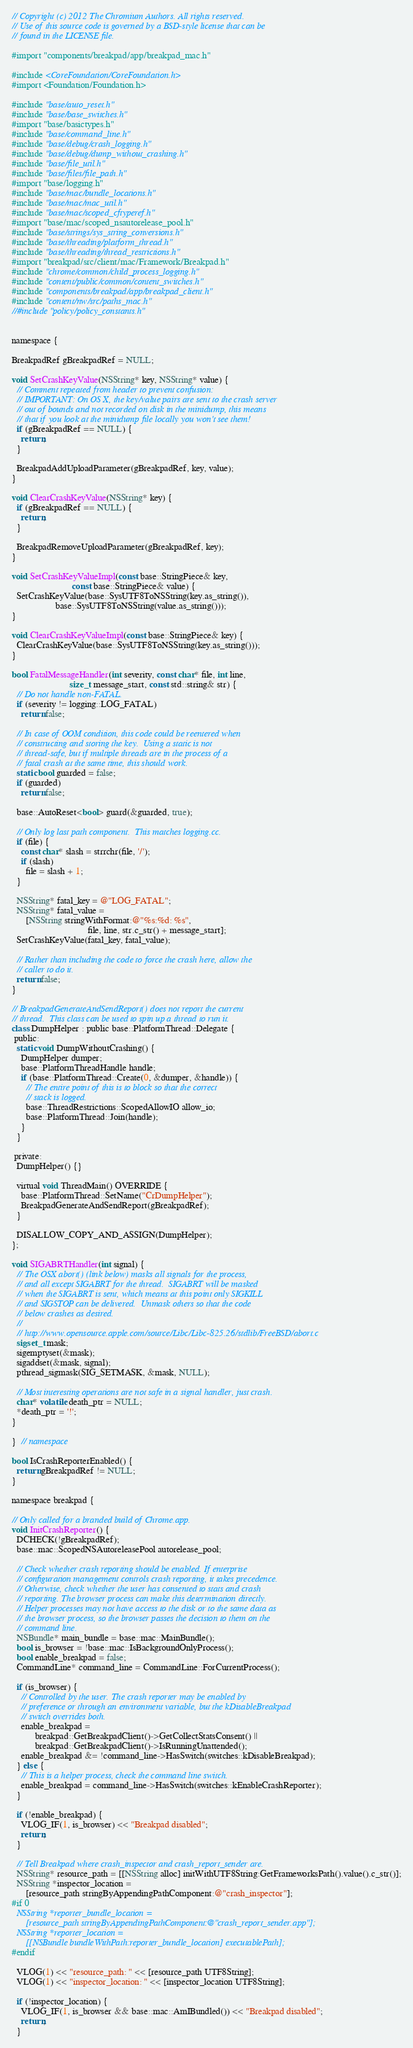Convert code to text. <code><loc_0><loc_0><loc_500><loc_500><_ObjectiveC_>// Copyright (c) 2012 The Chromium Authors. All rights reserved.
// Use of this source code is governed by a BSD-style license that can be
// found in the LICENSE file.

#import "components/breakpad/app/breakpad_mac.h"

#include <CoreFoundation/CoreFoundation.h>
#import <Foundation/Foundation.h>

#include "base/auto_reset.h"
#include "base/base_switches.h"
#import "base/basictypes.h"
#include "base/command_line.h"
#include "base/debug/crash_logging.h"
#include "base/debug/dump_without_crashing.h"
#include "base/file_util.h"
#include "base/files/file_path.h"
#import "base/logging.h"
#include "base/mac/bundle_locations.h"
#include "base/mac/mac_util.h"
#include "base/mac/scoped_cftyperef.h"
#import "base/mac/scoped_nsautorelease_pool.h"
#include "base/strings/sys_string_conversions.h"
#include "base/threading/platform_thread.h"
#include "base/threading/thread_restrictions.h"
#import "breakpad/src/client/mac/Framework/Breakpad.h"
#include "chrome/common/child_process_logging.h"
#include "content/public/common/content_switches.h"
#include "components/breakpad/app/breakpad_client.h"
#include "content/nw/src/paths_mac.h"
//#include "policy/policy_constants.h"


namespace {

BreakpadRef gBreakpadRef = NULL;

void SetCrashKeyValue(NSString* key, NSString* value) {
  // Comment repeated from header to prevent confusion:
  // IMPORTANT: On OS X, the key/value pairs are sent to the crash server
  // out of bounds and not recorded on disk in the minidump, this means
  // that if you look at the minidump file locally you won't see them!
  if (gBreakpadRef == NULL) {
    return;
  }

  BreakpadAddUploadParameter(gBreakpadRef, key, value);
}

void ClearCrashKeyValue(NSString* key) {
  if (gBreakpadRef == NULL) {
    return;
  }

  BreakpadRemoveUploadParameter(gBreakpadRef, key);
}

void SetCrashKeyValueImpl(const base::StringPiece& key,
                          const base::StringPiece& value) {
  SetCrashKeyValue(base::SysUTF8ToNSString(key.as_string()),
                   base::SysUTF8ToNSString(value.as_string()));
}

void ClearCrashKeyValueImpl(const base::StringPiece& key) {
  ClearCrashKeyValue(base::SysUTF8ToNSString(key.as_string()));
}

bool FatalMessageHandler(int severity, const char* file, int line,
                         size_t message_start, const std::string& str) {
  // Do not handle non-FATAL.
  if (severity != logging::LOG_FATAL)
    return false;

  // In case of OOM condition, this code could be reentered when
  // constructing and storing the key.  Using a static is not
  // thread-safe, but if multiple threads are in the process of a
  // fatal crash at the same time, this should work.
  static bool guarded = false;
  if (guarded)
    return false;

  base::AutoReset<bool> guard(&guarded, true);

  // Only log last path component.  This matches logging.cc.
  if (file) {
    const char* slash = strrchr(file, '/');
    if (slash)
      file = slash + 1;
  }

  NSString* fatal_key = @"LOG_FATAL";
  NSString* fatal_value =
      [NSString stringWithFormat:@"%s:%d: %s",
                                 file, line, str.c_str() + message_start];
  SetCrashKeyValue(fatal_key, fatal_value);

  // Rather than including the code to force the crash here, allow the
  // caller to do it.
  return false;
}

// BreakpadGenerateAndSendReport() does not report the current
// thread.  This class can be used to spin up a thread to run it.
class DumpHelper : public base::PlatformThread::Delegate {
 public:
  static void DumpWithoutCrashing() {
    DumpHelper dumper;
    base::PlatformThreadHandle handle;
    if (base::PlatformThread::Create(0, &dumper, &handle)) {
      // The entire point of this is to block so that the correct
      // stack is logged.
      base::ThreadRestrictions::ScopedAllowIO allow_io;
      base::PlatformThread::Join(handle);
    }
  }

 private:
  DumpHelper() {}

  virtual void ThreadMain() OVERRIDE {
    base::PlatformThread::SetName("CrDumpHelper");
    BreakpadGenerateAndSendReport(gBreakpadRef);
  }

  DISALLOW_COPY_AND_ASSIGN(DumpHelper);
};

void SIGABRTHandler(int signal) {
  // The OSX abort() (link below) masks all signals for the process,
  // and all except SIGABRT for the thread.  SIGABRT will be masked
  // when the SIGABRT is sent, which means at this point only SIGKILL
  // and SIGSTOP can be delivered.  Unmask others so that the code
  // below crashes as desired.
  //
  // http://www.opensource.apple.com/source/Libc/Libc-825.26/stdlib/FreeBSD/abort.c
  sigset_t mask;
  sigemptyset(&mask);
  sigaddset(&mask, signal);
  pthread_sigmask(SIG_SETMASK, &mask, NULL);

  // Most interesting operations are not safe in a signal handler, just crash.
  char* volatile death_ptr = NULL;
  *death_ptr = '!';
}

}  // namespace

bool IsCrashReporterEnabled() {
  return gBreakpadRef != NULL;
}

namespace breakpad {

// Only called for a branded build of Chrome.app.
void InitCrashReporter() {
  DCHECK(!gBreakpadRef);
  base::mac::ScopedNSAutoreleasePool autorelease_pool;

  // Check whether crash reporting should be enabled. If enterprise
  // configuration management controls crash reporting, it takes precedence.
  // Otherwise, check whether the user has consented to stats and crash
  // reporting. The browser process can make this determination directly.
  // Helper processes may not have access to the disk or to the same data as
  // the browser process, so the browser passes the decision to them on the
  // command line.
  NSBundle* main_bundle = base::mac::MainBundle();
  bool is_browser = !base::mac::IsBackgroundOnlyProcess();
  bool enable_breakpad = false;
  CommandLine* command_line = CommandLine::ForCurrentProcess();

  if (is_browser) {
    // Controlled by the user. The crash reporter may be enabled by
    // preference or through an environment variable, but the kDisableBreakpad
    // switch overrides both.
    enable_breakpad =
          breakpad::GetBreakpadClient()->GetCollectStatsConsent() ||
          breakpad::GetBreakpadClient()->IsRunningUnattended();
    enable_breakpad &= !command_line->HasSwitch(switches::kDisableBreakpad);
  } else {
    // This is a helper process, check the command line switch.
    enable_breakpad = command_line->HasSwitch(switches::kEnableCrashReporter);
  }

  if (!enable_breakpad) {
    VLOG_IF(1, is_browser) << "Breakpad disabled";
    return;
  }

  // Tell Breakpad where crash_inspector and crash_report_sender are.
  NSString* resource_path = [[NSString alloc] initWithUTF8String:GetFrameworksPath().value().c_str()];
  NSString *inspector_location =
      [resource_path stringByAppendingPathComponent:@"crash_inspector"];
#if 0
  NSString *reporter_bundle_location =
      [resource_path stringByAppendingPathComponent:@"crash_report_sender.app"];
  NSString *reporter_location =
      [[NSBundle bundleWithPath:reporter_bundle_location] executablePath];
#endif

  VLOG(1) << "resource_path: " << [resource_path UTF8String];
  VLOG(1) << "inspector_location: " << [inspector_location UTF8String];

  if (!inspector_location) {
    VLOG_IF(1, is_browser && base::mac::AmIBundled()) << "Breakpad disabled";
    return;
  }
</code> 